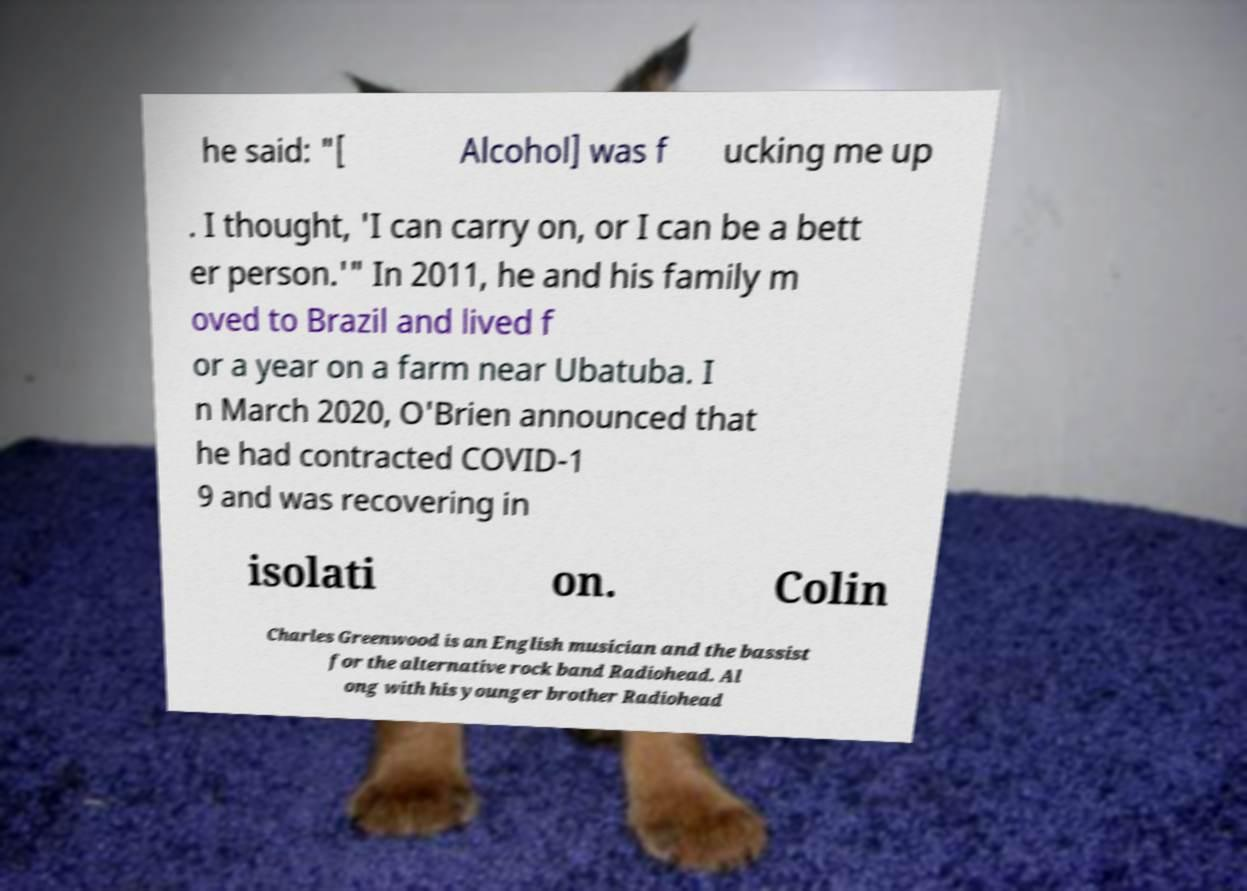What messages or text are displayed in this image? I need them in a readable, typed format. he said: "[ Alcohol] was f ucking me up . I thought, 'I can carry on, or I can be a bett er person.'" In 2011, he and his family m oved to Brazil and lived f or a year on a farm near Ubatuba. I n March 2020, O'Brien announced that he had contracted COVID-1 9 and was recovering in isolati on. Colin Charles Greenwood is an English musician and the bassist for the alternative rock band Radiohead. Al ong with his younger brother Radiohead 